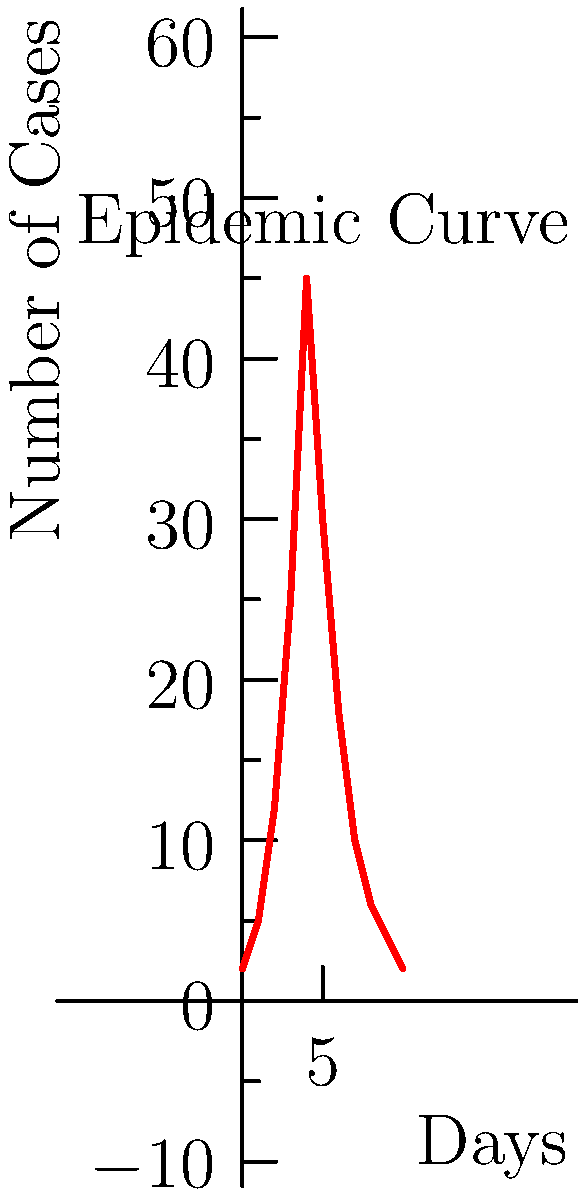As a public health officer, you are analyzing an epidemic curve for a disease outbreak in an industrial setting. The curve shows the number of new cases per day over a 10-day period. What is the most likely day of the index case (patient zero) based on the typical incubation period of 2-3 days for this disease? To determine the most likely day of the index case:

1. Identify the peak of the epidemic curve:
   The peak occurs on day 4 with 45 cases.

2. Consider the typical incubation period:
   The question states it's 2-3 days.

3. Count back from the peak:
   Counting back 2-3 days from day 4 gives us day 1 or 2.

4. Analyze the early part of the curve:
   There are already 5 cases on day 1, which is unlikely for a single index case.
   Day 0 shows 2 cases, which could represent the index case and perhaps one immediate contact.

5. Consider the shape of the curve:
   The steep rise between days 1-4 suggests rapid spread, consistent with an index case on day 0.

6. Conclusion:
   Day 0 is the most likely day for the index case, allowing for the 2-3 day incubation period before the rapid increase in cases.
Answer: Day 0 